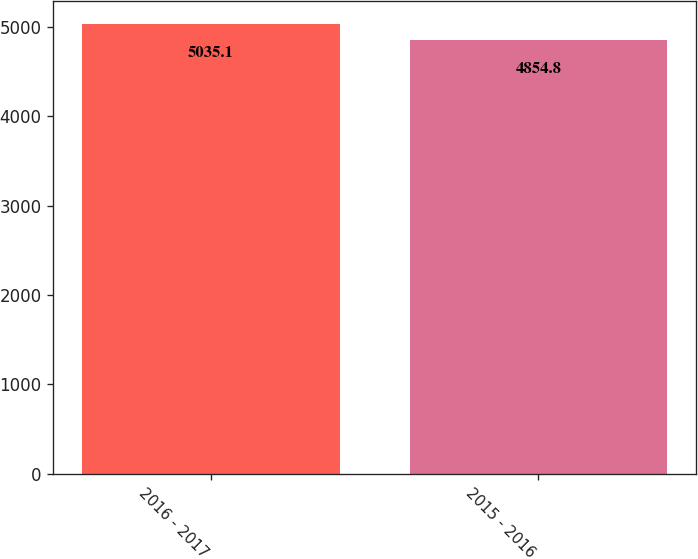Convert chart to OTSL. <chart><loc_0><loc_0><loc_500><loc_500><bar_chart><fcel>2016 - 2017<fcel>2015 - 2016<nl><fcel>5035.1<fcel>4854.8<nl></chart> 